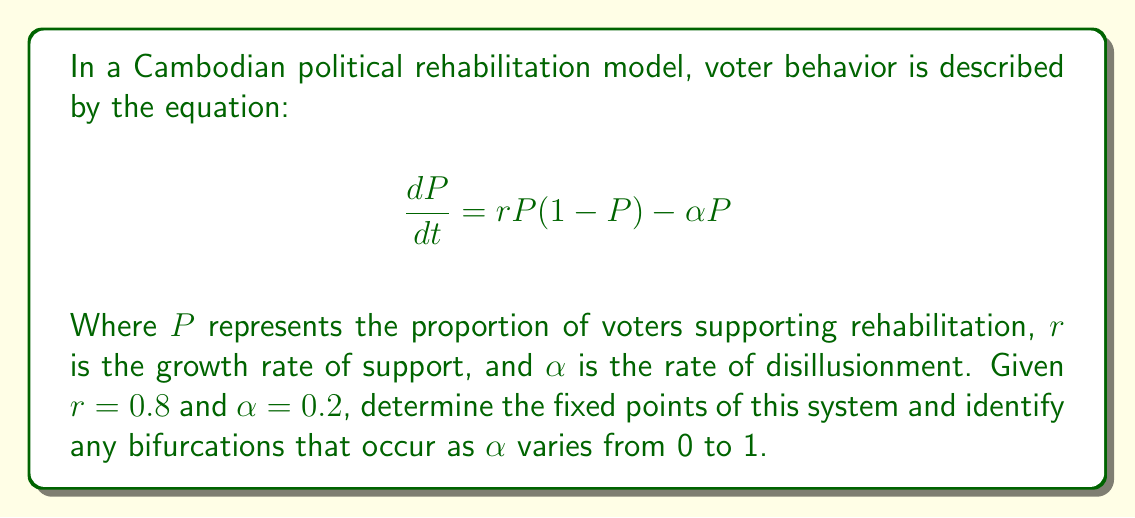Could you help me with this problem? 1. To find the fixed points, set $\frac{dP}{dt} = 0$:

   $$0 = rP(1-P) - \alpha P$$

2. Factor out $P$:

   $$0 = P(r(1-P) - \alpha)$$

3. Solve for $P$:
   
   a) $P = 0$ is one fixed point.
   
   b) For the other, solve $r(1-P) - \alpha = 0$:
      
      $$r - rP - \alpha = 0$$
      $$rP = r - \alpha$$
      $$P = \frac{r - \alpha}{r}$$

4. Substitute the given values $r = 0.8$ and $\alpha = 0.2$:

   $$P = \frac{0.8 - 0.2}{0.8} = \frac{0.6}{0.8} = 0.75$$

5. To identify bifurcations, examine how fixed points change as $\alpha$ varies:

   - When $\alpha < r$, there are two fixed points: 0 and $(r-\alpha)/r$.
   - When $\alpha = r$, the non-zero fixed point merges with 0.
   - When $\alpha > r$, only the 0 fixed point remains.

6. The bifurcation occurs when $\alpha = r = 0.8$. This is a transcritical bifurcation, where the stability of the fixed points exchanges.

[asy]
import graph;
size(200,150);
real f(real x) {return 0.8*x*(1-x);}
draw(graph(f,0,1));
draw((0,0)--(1,0.8),dashed);
draw((0,0)--(1,0),Arrow);
draw((0,0)--(0,0.8),Arrow);
label("P",(.95,0),S);
label("dP/dt",(0,0.75),W);
dot((0,0));
dot((0.75,0));
label("Fixed points",(0.75,0),SE);
[/asy]
Answer: Fixed points: $P = 0$ and $P = 0.75$. Transcritical bifurcation at $\alpha = 0.8$. 